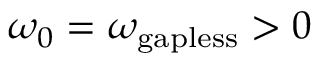Convert formula to latex. <formula><loc_0><loc_0><loc_500><loc_500>\omega _ { 0 } = \omega _ { g a p l e s s } > 0</formula> 